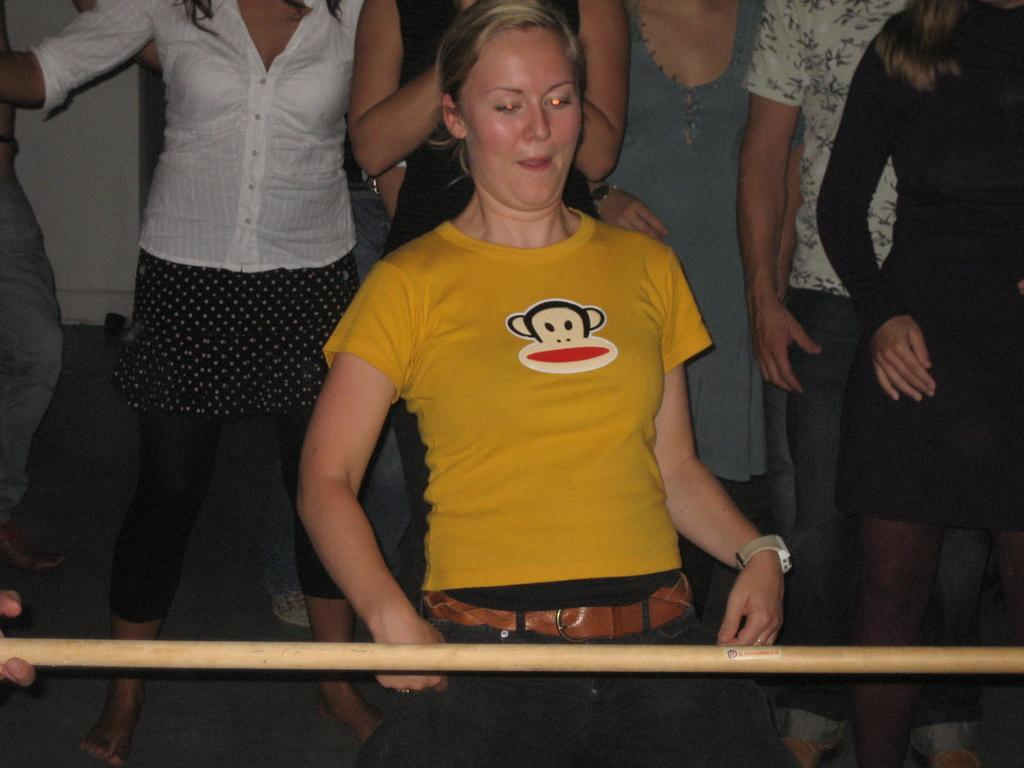What is the main subject of the image? There is a woman standing in the image. What object can be seen near the woman? There is a wooden stick in the image. Can you describe the background of the image? There is a group of people standing in the background of the image. How many hands are holding the bottle in the image? There is no bottle present in the image. What type of edge can be seen on the wooden stick in the image? The wooden stick in the image does not have a visible edge. 